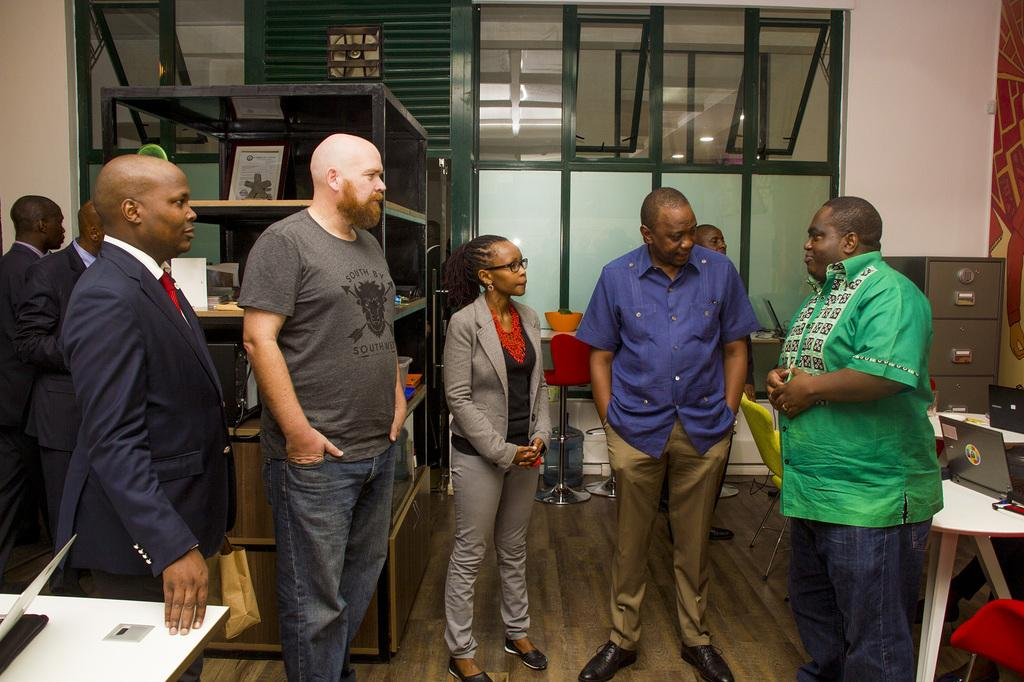What can be seen in the image? There are persons standing in the image. Where are the tables located in the image? There is a table in the left corner and another table in the right corner of the image. What is on the tables? There are objects on the tables. What else can be seen in the background of the image? There are other objects visible in the background of the image. What type of marble is being used to construct the hospital in the image? There is no hospital or marble present in the image; it features persons standing and tables with objects. Can you touch the objects in the image? The objects in the image are not physically present, so they cannot be touched. 